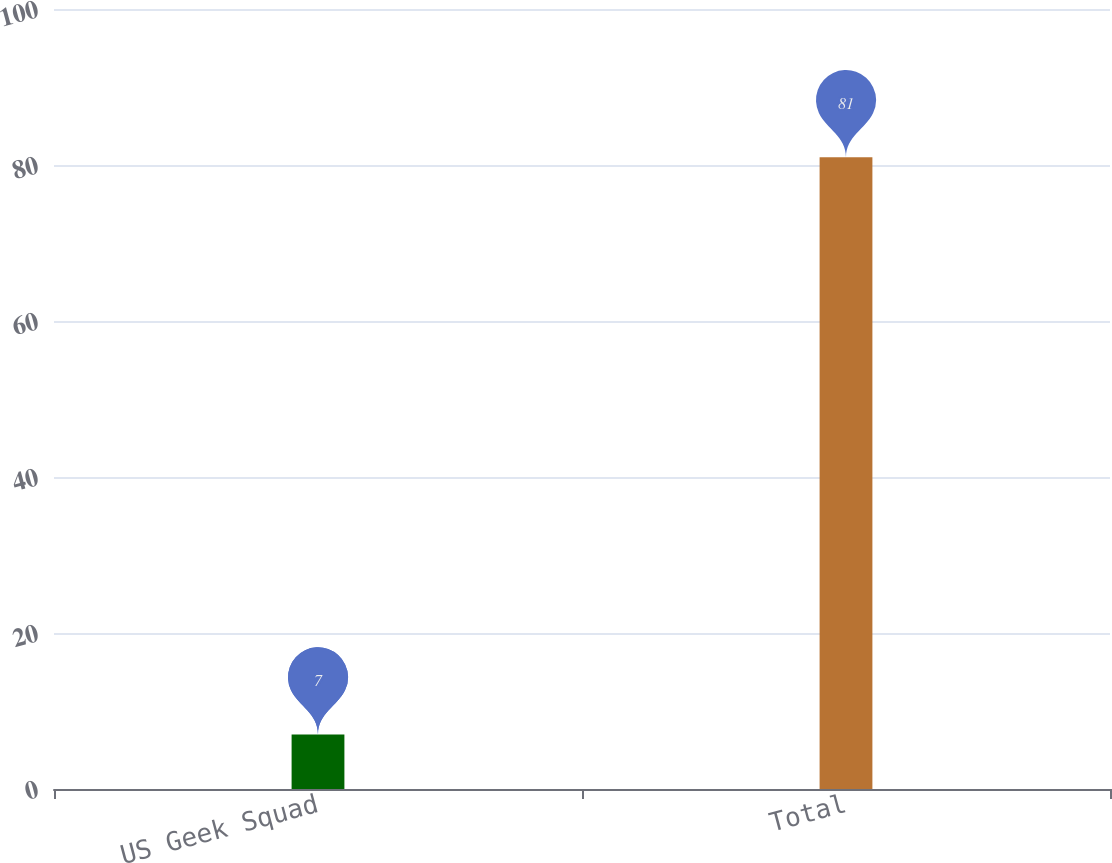Convert chart. <chart><loc_0><loc_0><loc_500><loc_500><bar_chart><fcel>US Geek Squad<fcel>Total<nl><fcel>7<fcel>81<nl></chart> 